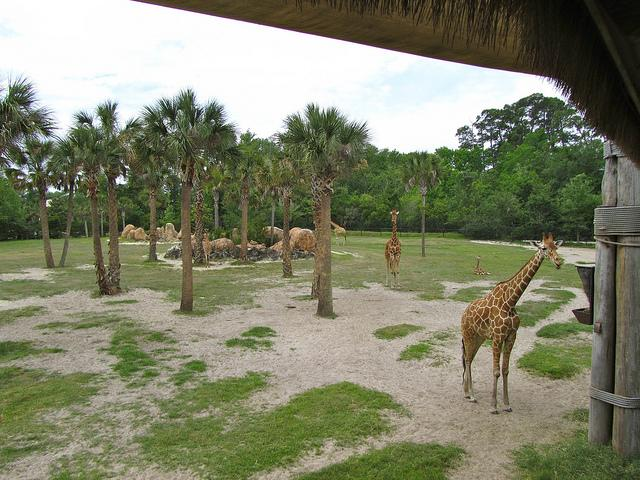What kind of structure is the animal all the way to the right looking at?

Choices:
A) diamond
B) wooden
C) brick
D) mud wooden 